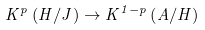Convert formula to latex. <formula><loc_0><loc_0><loc_500><loc_500>K ^ { p } \left ( H / J \right ) \rightarrow K ^ { 1 - p } \left ( A / H \right )</formula> 